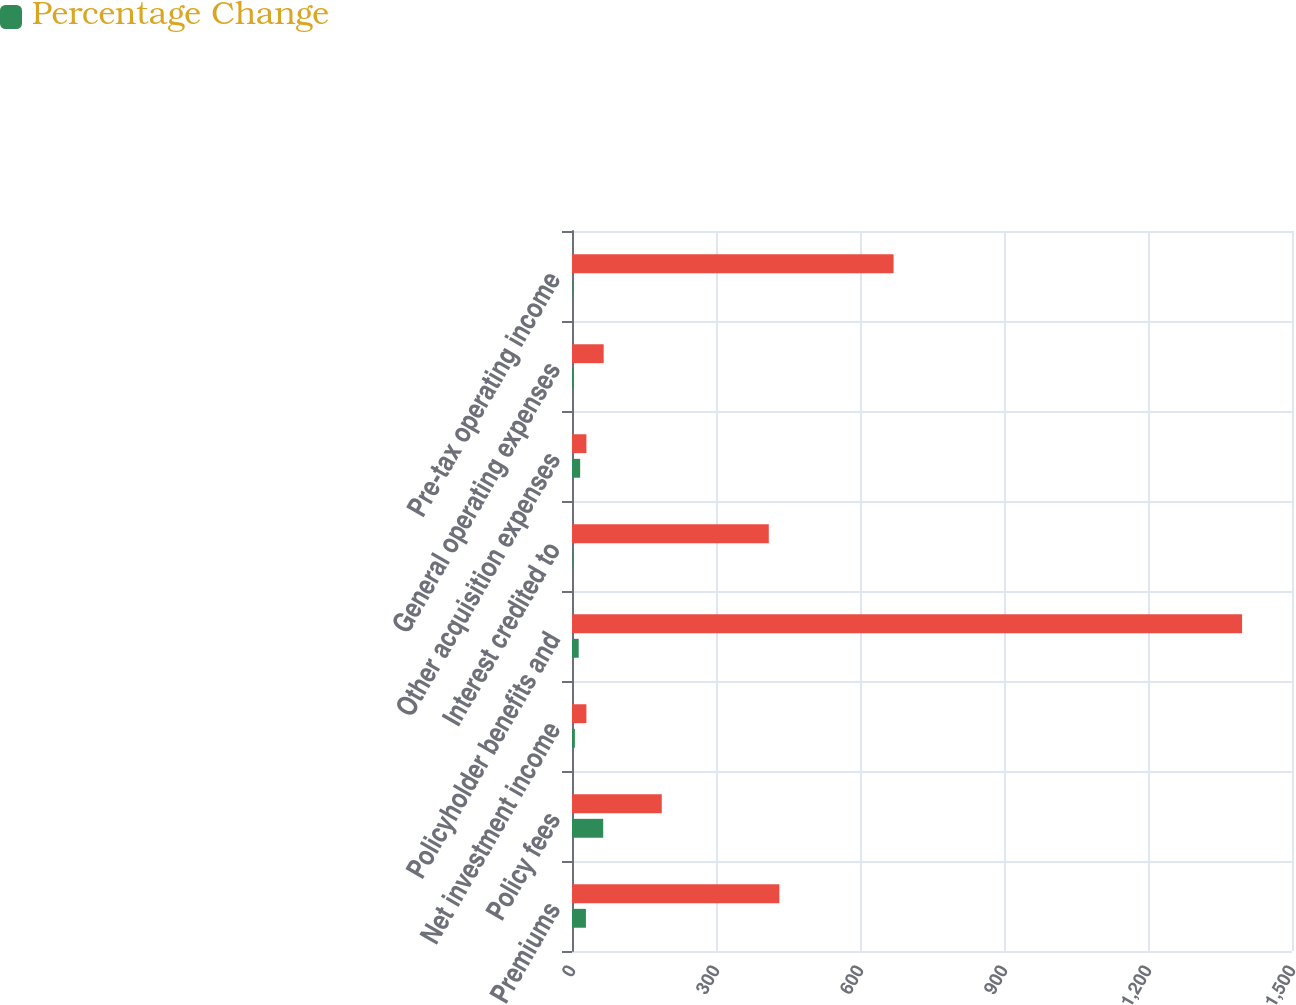<chart> <loc_0><loc_0><loc_500><loc_500><stacked_bar_chart><ecel><fcel>Premiums<fcel>Policy fees<fcel>Net investment income<fcel>Policyholder benefits and<fcel>Interest credited to<fcel>Other acquisition expenses<fcel>General operating expenses<fcel>Pre-tax operating income<nl><fcel>nan<fcel>432<fcel>187<fcel>30<fcel>1396<fcel>410<fcel>30<fcel>66<fcel>670<nl><fcel>Percentage Change<fcel>29<fcel>65<fcel>6<fcel>14<fcel>1<fcel>17<fcel>3<fcel>1<nl></chart> 